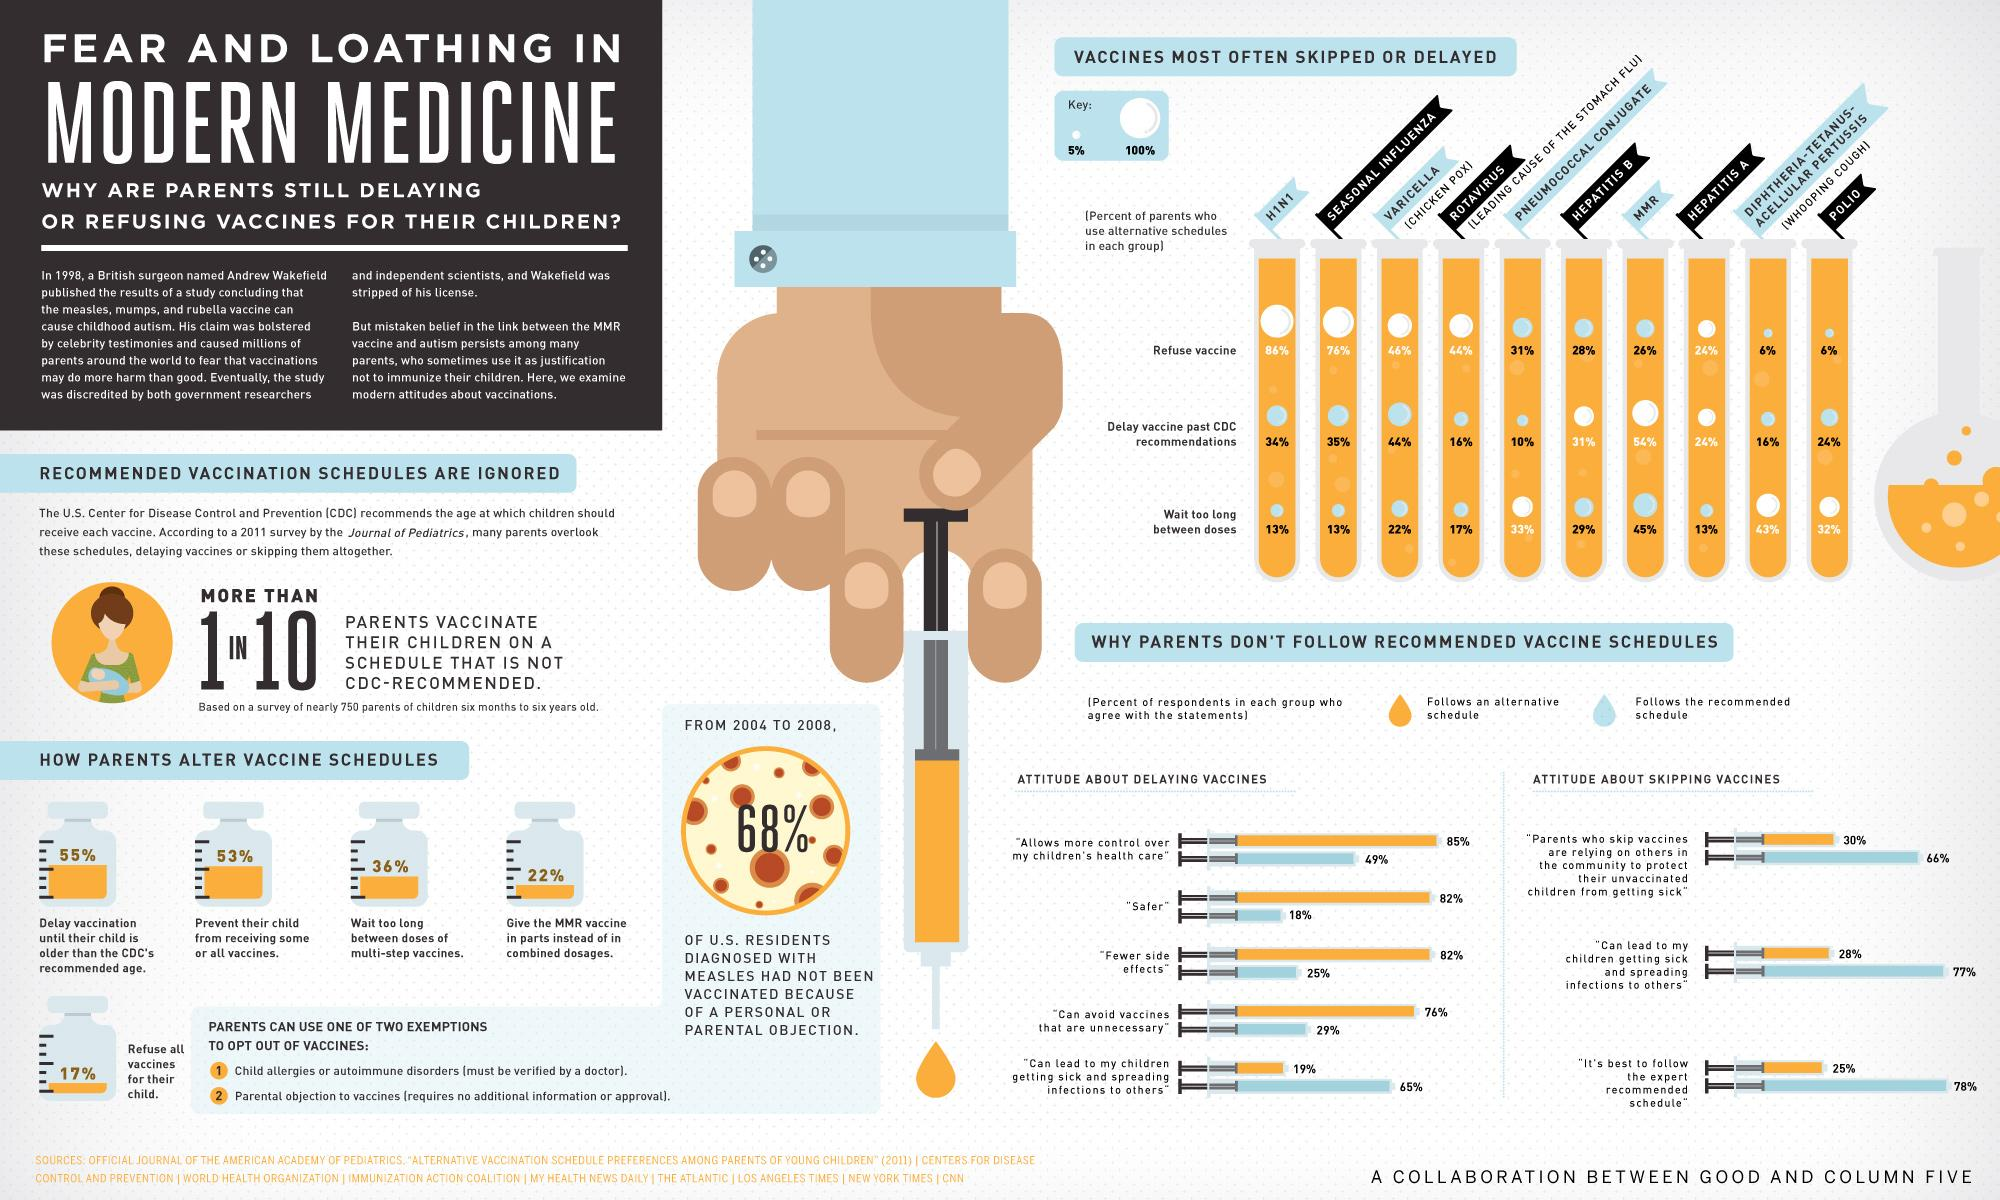Outline some significant characteristics in this image. The most commonly skipped vaccine among children aged 6 months to 6 years old in the United States, according to a survey, is the HINI vaccine. According to a survey, 22% of U.S. parents give the MMR vaccine in parts instead of in combined dosages. According to a survey, 55% of U.S. parents delay vaccinating their children until they are older than the recommended age set by the CDC. According to a survey, 44% of U.S. parents delay administering the Varicella vaccine to their children past the Centers for Disease Control and Prevention's recommended timeline. According to a recent survey, 53% of U.S. parents prevent their child from receiving some or all vaccines. 